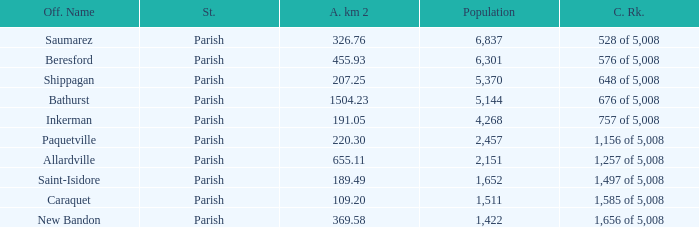What is the Area of the Saint-Isidore Parish with a Population smaller than 4,268? 189.49. 